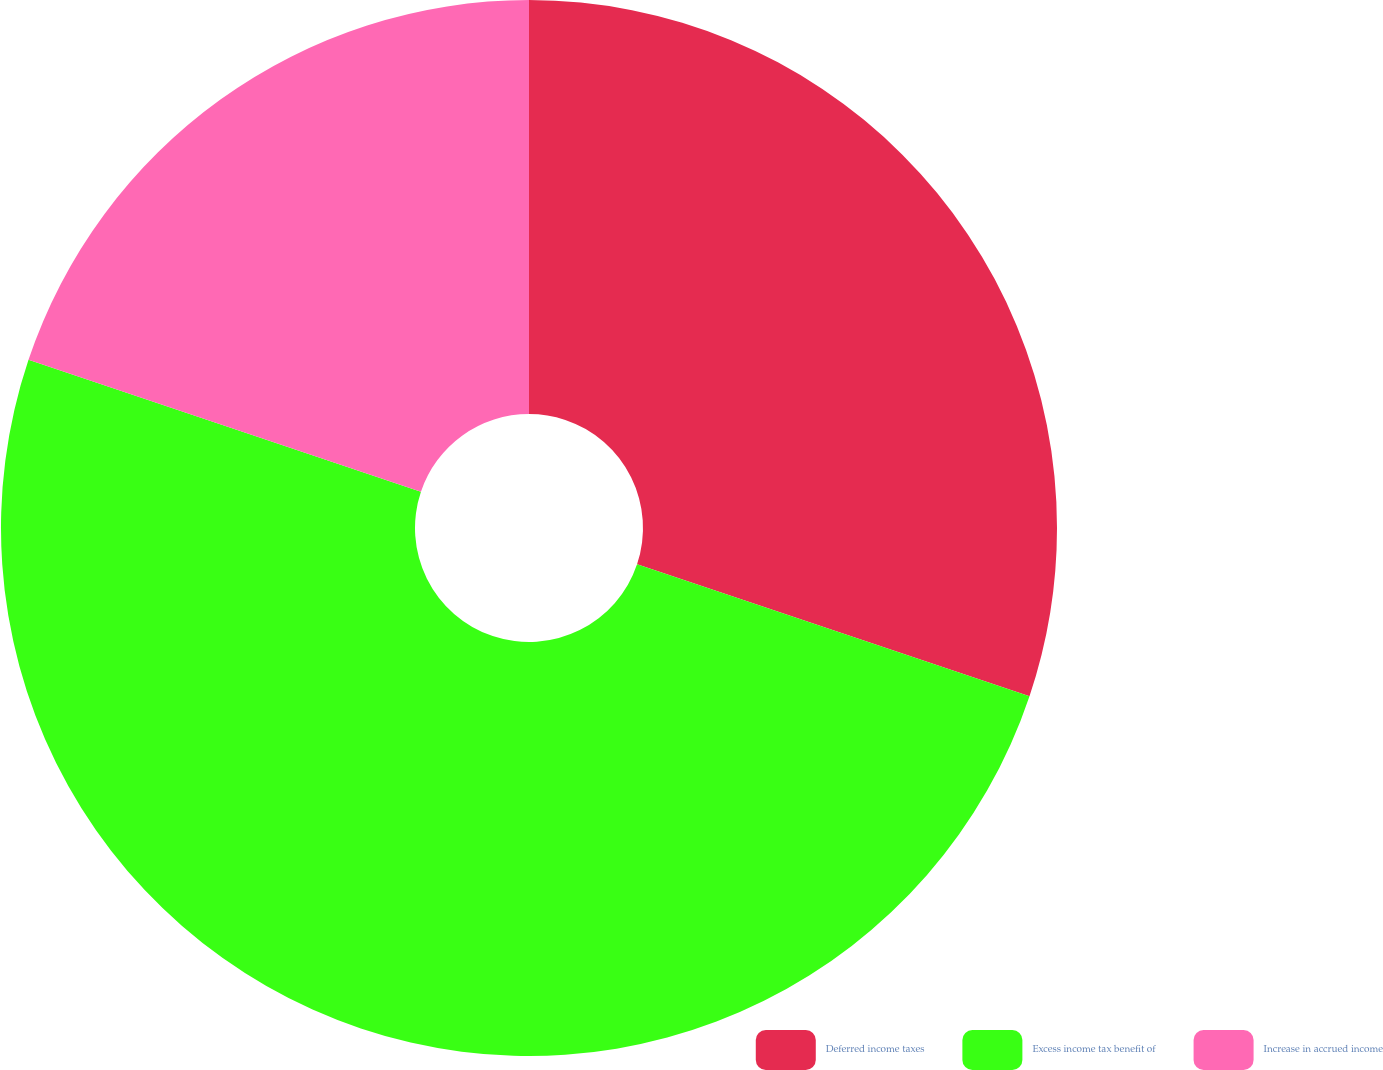<chart> <loc_0><loc_0><loc_500><loc_500><pie_chart><fcel>Deferred income taxes<fcel>Excess income tax benefit of<fcel>Increase in accrued income<nl><fcel>30.16%<fcel>50.0%<fcel>19.84%<nl></chart> 